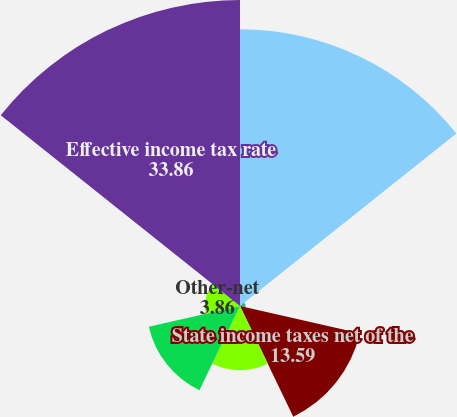Convert chart to OTSL. <chart><loc_0><loc_0><loc_500><loc_500><pie_chart><fcel>Federal statutory income tax<fcel>Meals and entertainment<fcel>State income taxes net of the<fcel>Tax-exempt interest income<fcel>Low-income housing tax credit<fcel>Other-net<fcel>Effective income tax rate<nl><fcel>30.62%<fcel>0.61%<fcel>13.59%<fcel>7.1%<fcel>10.35%<fcel>3.86%<fcel>33.86%<nl></chart> 